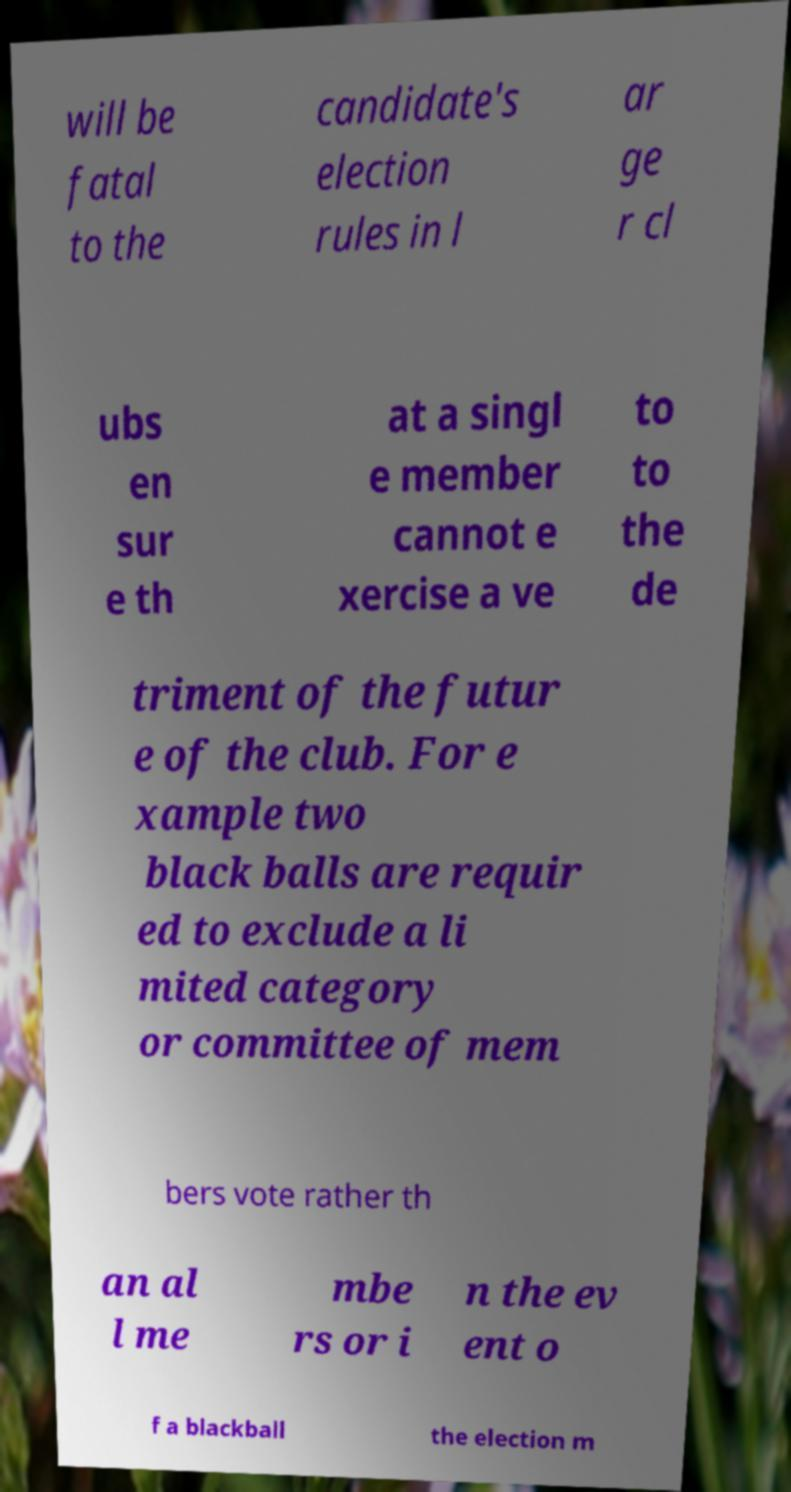Please read and relay the text visible in this image. What does it say? will be fatal to the candidate's election rules in l ar ge r cl ubs en sur e th at a singl e member cannot e xercise a ve to to the de triment of the futur e of the club. For e xample two black balls are requir ed to exclude a li mited category or committee of mem bers vote rather th an al l me mbe rs or i n the ev ent o f a blackball the election m 